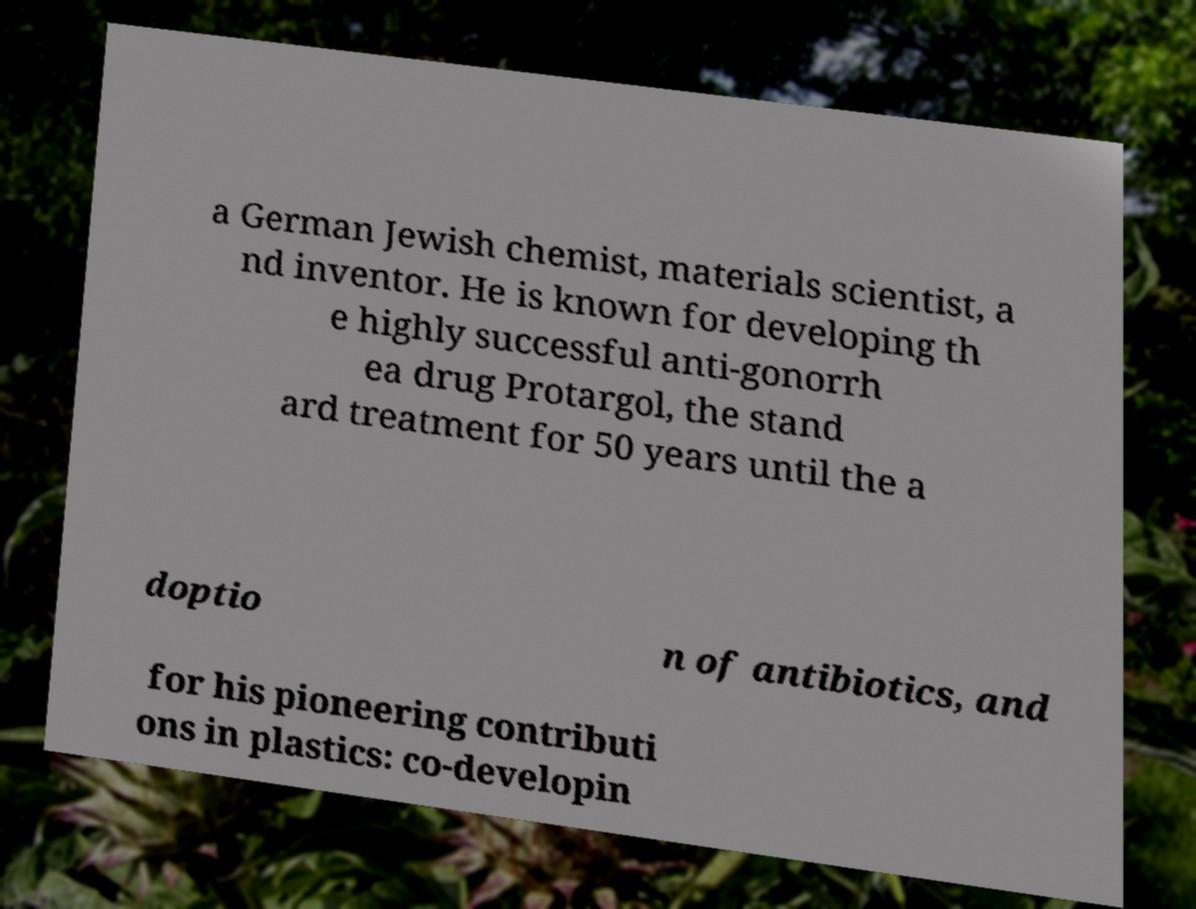What messages or text are displayed in this image? I need them in a readable, typed format. a German Jewish chemist, materials scientist, a nd inventor. He is known for developing th e highly successful anti-gonorrh ea drug Protargol, the stand ard treatment for 50 years until the a doptio n of antibiotics, and for his pioneering contributi ons in plastics: co-developin 